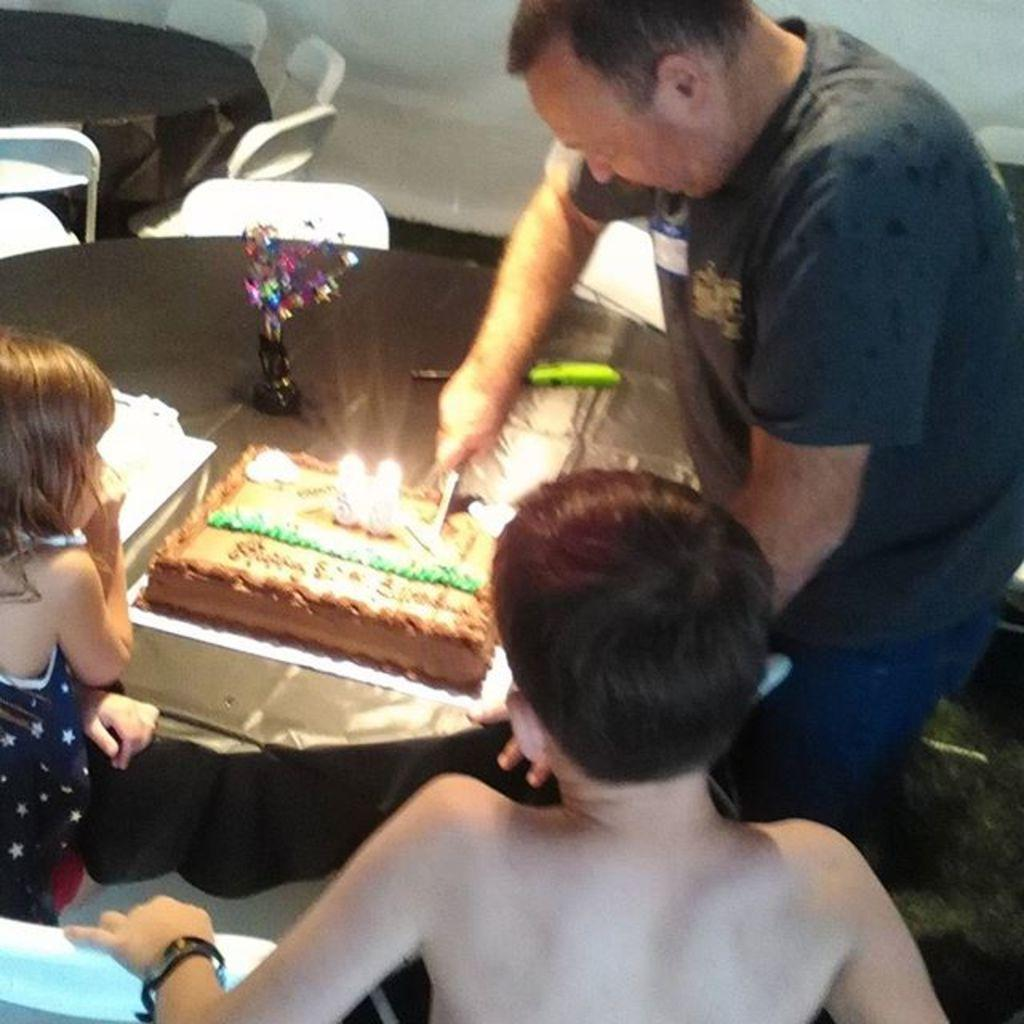What is the person in the image doing? There is a person cutting a cake in the image. How many people are present in the image? There are two people in the image. What is the primary piece of furniture in the image? There is a table in the image. What decorative item can be seen on the table? There is a flower vase on the table. What type of seating is visible in the image? There are chairs in the image. What architectural feature is visible in the background? There is a wall visible in the image. How many children are playing on the side of the image? There are no children present in the image, and no side of the image is mentioned. Is the cake poisoned in the image? There is no indication in the image that the cake is poisoned, and it is not appropriate to make assumptions about the safety of the food. 